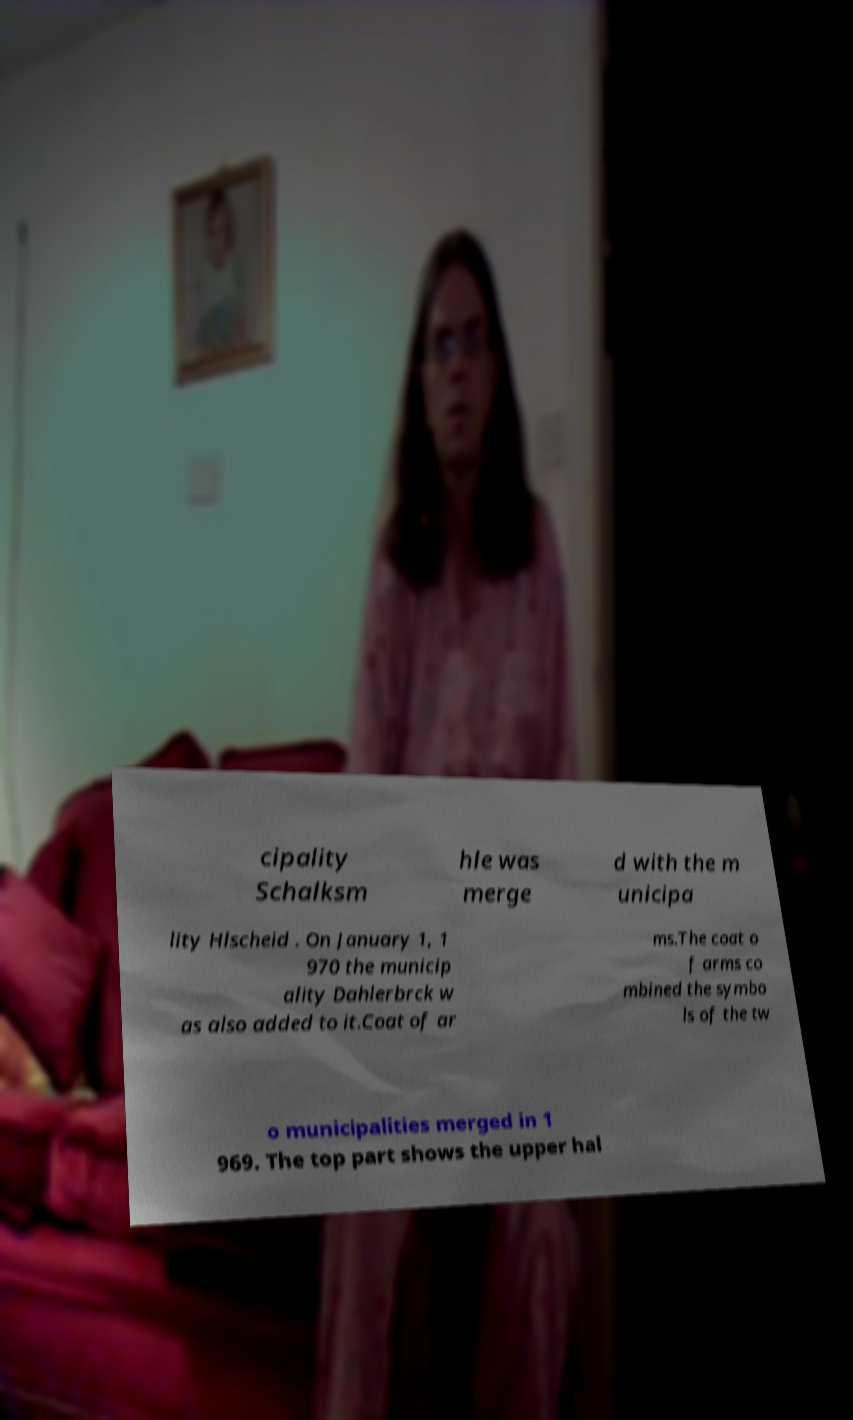Could you assist in decoding the text presented in this image and type it out clearly? cipality Schalksm hle was merge d with the m unicipa lity Hlscheid . On January 1, 1 970 the municip ality Dahlerbrck w as also added to it.Coat of ar ms.The coat o f arms co mbined the symbo ls of the tw o municipalities merged in 1 969. The top part shows the upper hal 